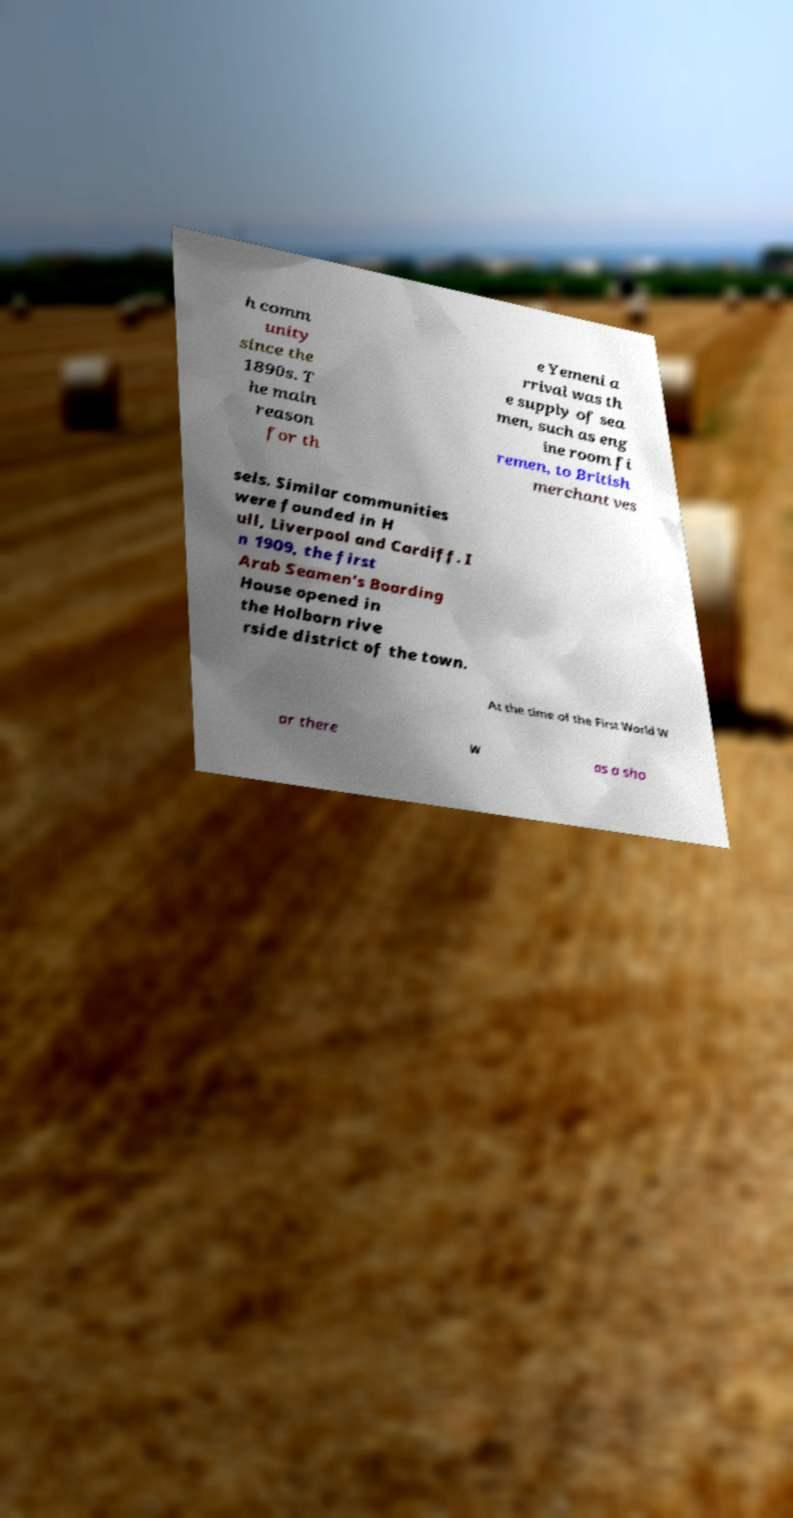Can you read and provide the text displayed in the image?This photo seems to have some interesting text. Can you extract and type it out for me? h comm unity since the 1890s. T he main reason for th e Yemeni a rrival was th e supply of sea men, such as eng ine room fi remen, to British merchant ves sels. Similar communities were founded in H ull, Liverpool and Cardiff. I n 1909, the first Arab Seamen's Boarding House opened in the Holborn rive rside district of the town. At the time of the First World W ar there w as a sho 